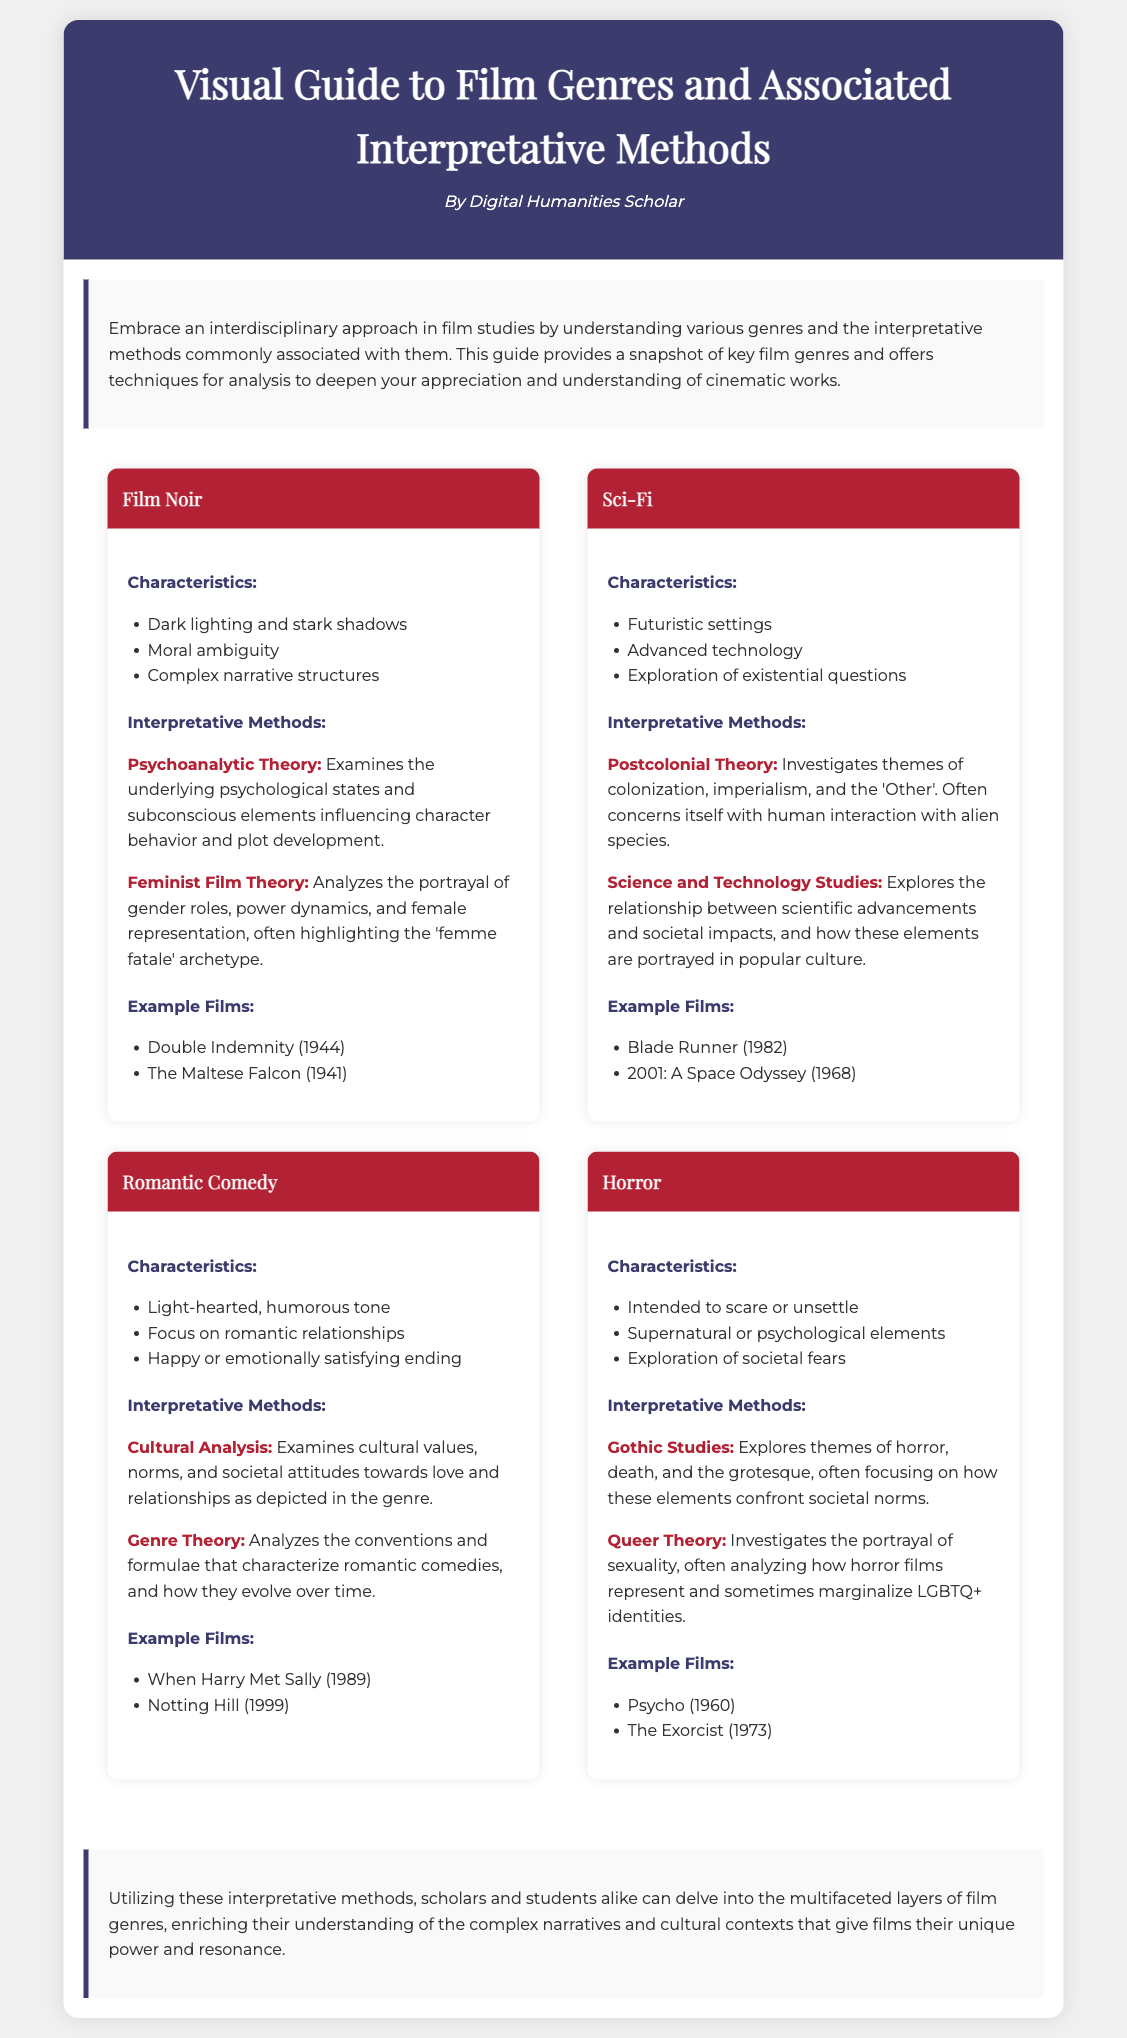What is the title of the document? The title is presented in the header section of the document.
Answer: Visual Guide to Film Genres and Associated Interpretative Methods Who is the author of the document? The author is mentioned just below the title in the header.
Answer: Digital Humanities Scholar Name one example film from the Film Noir genre. The document lists example films under each genre section.
Answer: Double Indemnity (1944) What are the characteristics of the Sci-Fi genre? Characteristics are outlined in bullet points within the respective genre sections.
Answer: Futuristic settings, Advanced technology, Exploration of existential questions Which interpretative method is associated with the Horror genre? Interpretative methods are listed in the genre sections and include several types.
Answer: Gothic Studies How many example films are listed under Romantic Comedy? The number of films is indicated in the example films section for that genre.
Answer: 2 Which genre features the method "Feminist Film Theory"? This method appears under the interpretative methods of a specific genre section in the document.
Answer: Film Noir What type of film is "Blade Runner"? The example films indicate the genre classification within the document's context.
Answer: Sci-Fi 